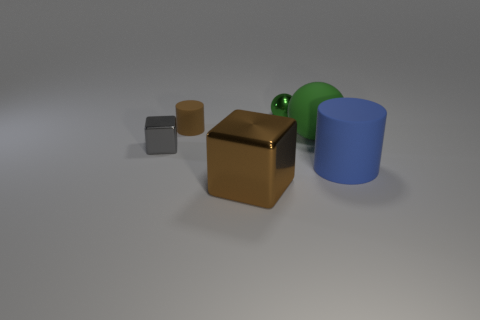Add 1 matte balls. How many objects exist? 7 Subtract all spheres. How many objects are left? 4 Add 2 small metal cubes. How many small metal cubes are left? 3 Add 5 brown rubber cylinders. How many brown rubber cylinders exist? 6 Subtract 0 purple cylinders. How many objects are left? 6 Subtract all large green metal spheres. Subtract all tiny gray things. How many objects are left? 5 